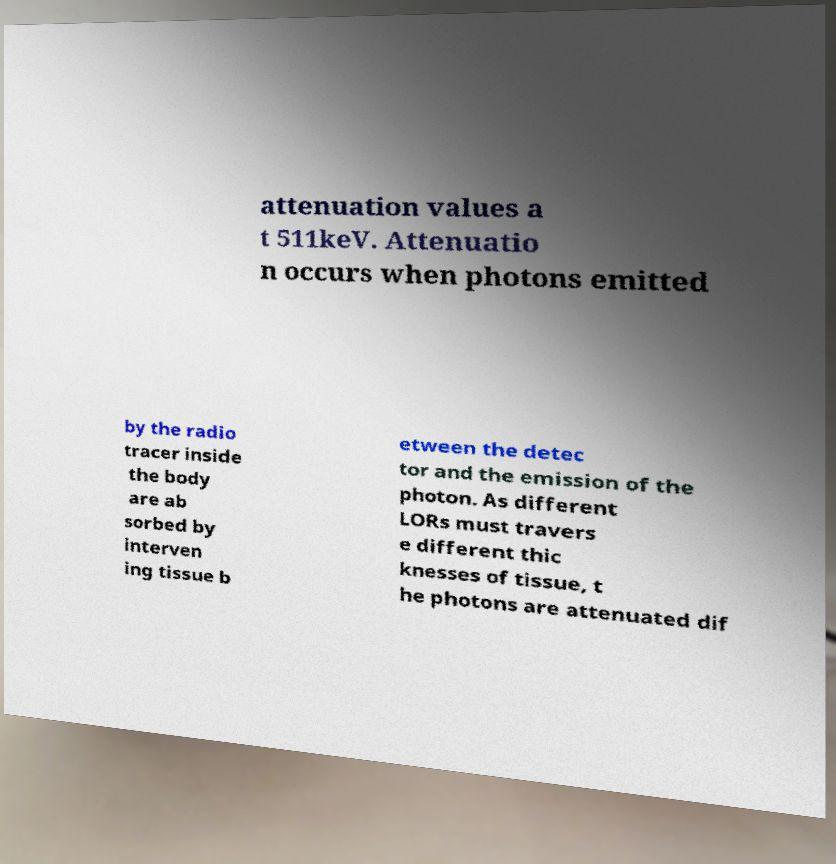Could you extract and type out the text from this image? attenuation values a t 511keV. Attenuatio n occurs when photons emitted by the radio tracer inside the body are ab sorbed by interven ing tissue b etween the detec tor and the emission of the photon. As different LORs must travers e different thic knesses of tissue, t he photons are attenuated dif 